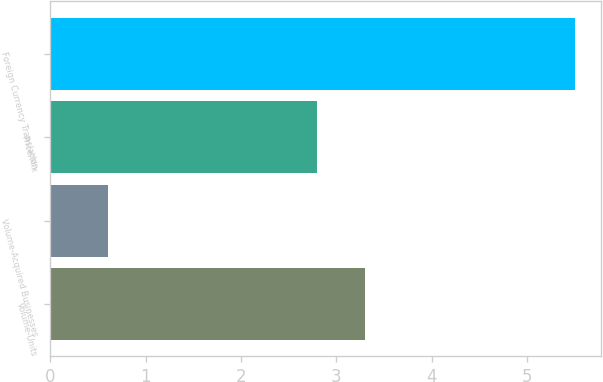Convert chart. <chart><loc_0><loc_0><loc_500><loc_500><bar_chart><fcel>Volume-Units<fcel>Volume-Acquired Businesses<fcel>Price/Mix<fcel>Foreign Currency Translation<nl><fcel>3.3<fcel>0.6<fcel>2.8<fcel>5.5<nl></chart> 